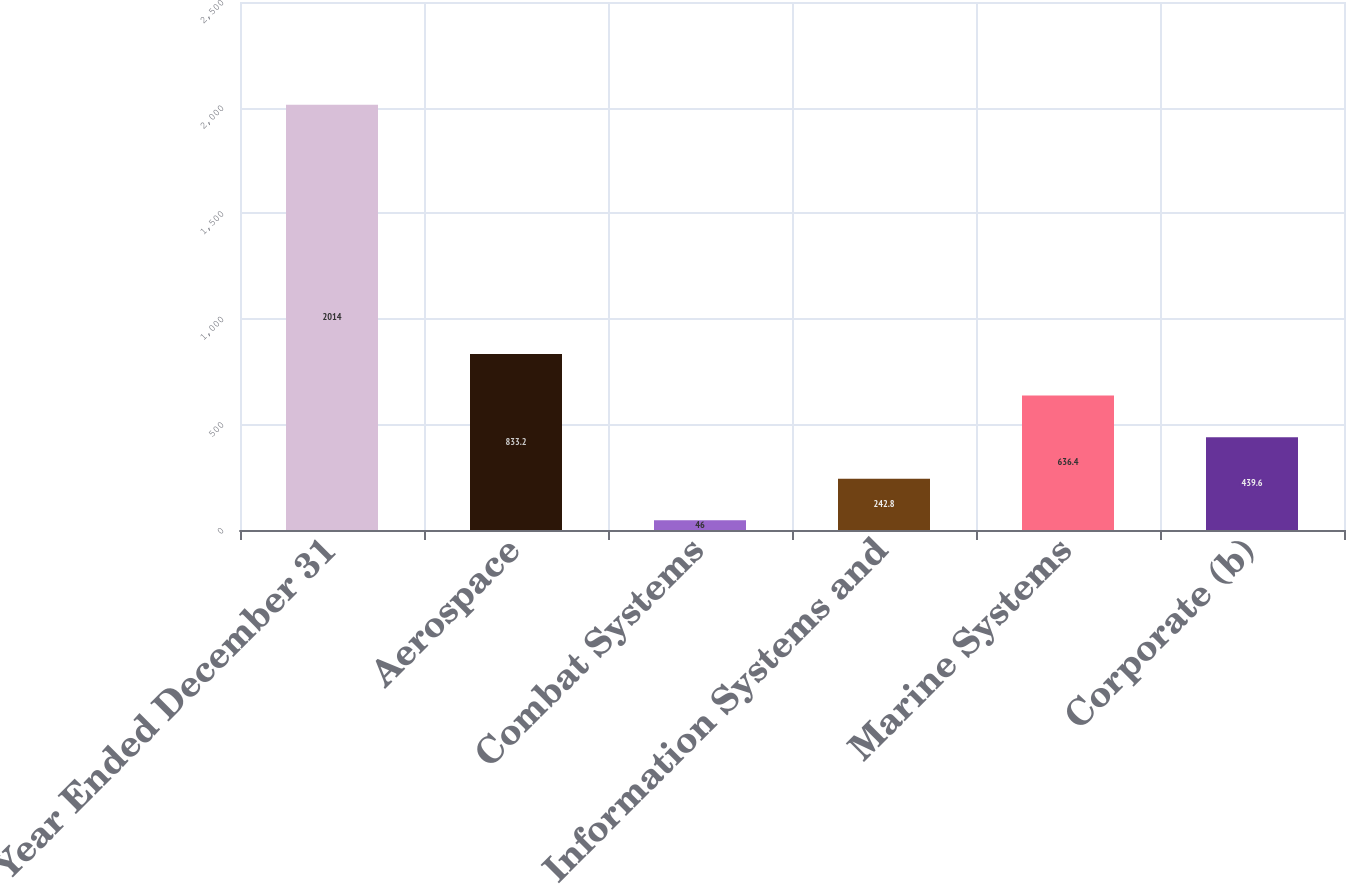Convert chart. <chart><loc_0><loc_0><loc_500><loc_500><bar_chart><fcel>Year Ended December 31<fcel>Aerospace<fcel>Combat Systems<fcel>Information Systems and<fcel>Marine Systems<fcel>Corporate (b)<nl><fcel>2014<fcel>833.2<fcel>46<fcel>242.8<fcel>636.4<fcel>439.6<nl></chart> 